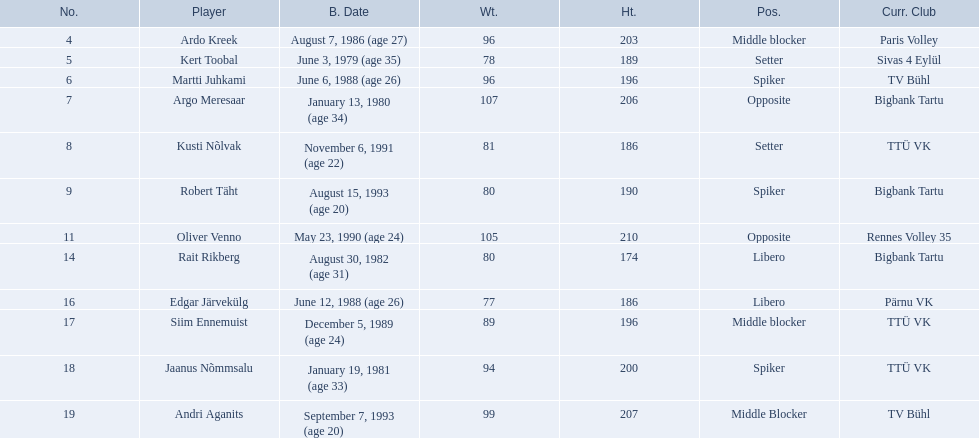Who are the players of the estonian men's national volleyball team? Ardo Kreek, Kert Toobal, Martti Juhkami, Argo Meresaar, Kusti Nõlvak, Robert Täht, Oliver Venno, Rait Rikberg, Edgar Järvekülg, Siim Ennemuist, Jaanus Nõmmsalu, Andri Aganits. Of these, which have a height over 200? Ardo Kreek, Argo Meresaar, Oliver Venno, Andri Aganits. Of the remaining, who is the tallest? Oliver Venno. 